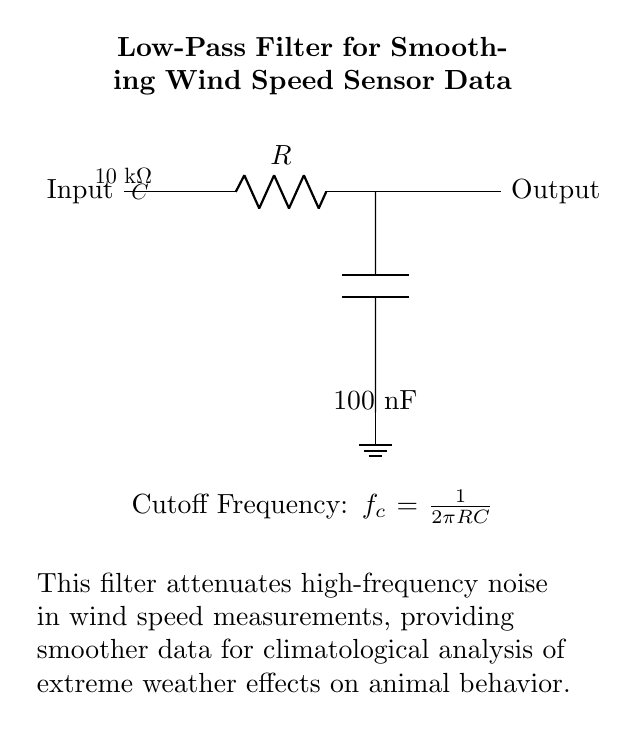What type of filter is depicted in the circuit? The circuit is a low-pass filter, which allows low-frequency signals to pass while attenuating high-frequency signals. This is inferred from its definition in the title and the component arrangement.
Answer: low-pass filter What are the values of the resistor and capacitor in this circuit? The resistor has a value of ten thousand ohms, indicated by the label on the resistor in the circuit. The capacitor has a value of one hundred nanofarads, as shown next to the capacitor symbol.
Answer: ten thousand ohms and one hundred nanofarads What is the formula for the cutoff frequency in this circuit? The cutoff frequency formula given in the circuit is expressed as one over two pi times the product of the resistor and capacitor values. This is a standard formula for calculating the cutoff frequency in a low-pass filter configuration.
Answer: one over two pi RC How does this filter affect wind speed measurements? The filter attenuates high-frequency noise in the wind speed measurements. This smoothing effect helps in providing cleaner data, which is essential for climatological analysis, particularly when investigating the impact of extreme weather on animal behavior.
Answer: It smooths the data What is the purpose of the capacitor in this low-pass filter? The capacitor in a low-pass filter serves to store and release charge; it helps to smooth out rapid changes in voltage by temporarily storing energy and thereby reducing high-frequency fluctuations in the output. This is crucial for accurate sensor readings of wind speed.
Answer: Smooths voltage fluctuations What happens to high-frequency signals in this circuit? High-frequency signals are significantly attenuated in a low-pass filter. This is due to the reactive nature of the capacitor, which restricts high-frequency components of the signal from passing through to the output.
Answer: They are attenuated What is indicated by the output label in the circuit? The output label signifies where the filtered voltage signal can be accessed, which represents the smoothed wind speed data after removing high-frequency noise. This output is crucial for further analysis in climatological studies.
Answer: Filtered wind speed data output 